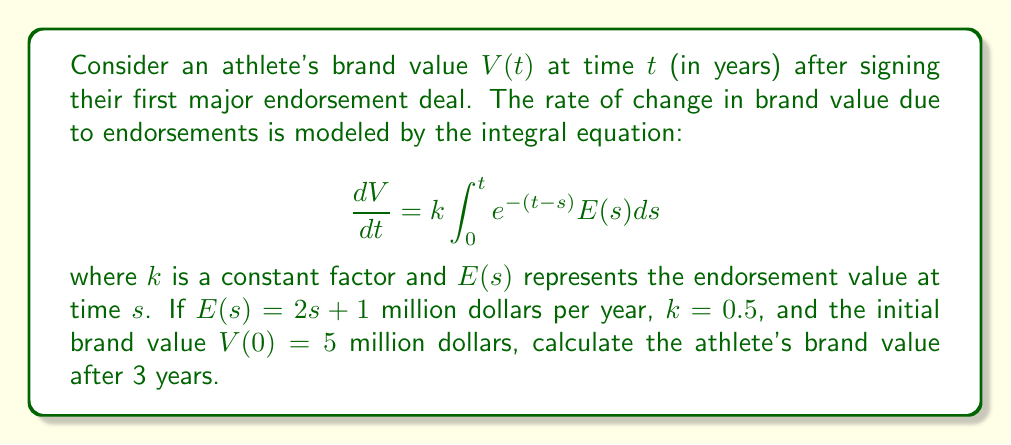Provide a solution to this math problem. To solve this problem, we'll follow these steps:

1) First, we need to solve the integral equation to find $V(t)$:

   $$\frac{dV}{dt} = k\int_0^t e^{-(t-s)}E(s)ds$$

2) Substitute the given $E(s) = 2s + 1$:

   $$\frac{dV}{dt} = k\int_0^t e^{-(t-s)}(2s + 1)ds$$

3) Solve the integral:

   $$\begin{align*}
   \frac{dV}{dt} &= k\int_0^t e^{-(t-s)}(2s + 1)ds \\
   &= k\left[-e^{-(t-s)}(2s + 1) - 2e^{-(t-s)}\right]_0^t \\
   &= k\left[-(2t + 1) - 2 + (1 + 2e^{-t})\right] \\
   &= k(-2t + 2e^{-t} - 1)
   \end{align*}$$

4) Integrate both sides with respect to $t$:

   $$\begin{align*}
   V(t) &= k\int (-2t + 2e^{-t} - 1)dt \\
   &= k(-t^2 - 2e^{-t} - t) + C
   \end{align*}$$

5) Use the initial condition $V(0) = 5$ to find $C$:

   $$5 = k(0 - 2 - 0) + C$$
   $$C = 5 + 2k$$

6) Therefore, the brand value function is:

   $$V(t) = k(-t^2 - 2e^{-t} - t) + 5 + 2k$$

7) Substitute $k = 0.5$ and $t = 3$:

   $$\begin{align*}
   V(3) &= 0.5(-3^2 - 2e^{-3} - 3) + 5 + 2(0.5) \\
   &= 0.5(-9 - 2e^{-3} - 3) + 6 \\
   &= -4.5 - e^{-3} - 1.5 + 6 \\
   &= 0 - e^{-3}
   \end{align*}$$

8) Evaluate $e^{-3} \approx 0.0498$:

   $$V(3) \approx 0 - 0.0498 = -0.0498$$

Therefore, the athlete's brand value after 3 years is approximately -0.0498 million dollars, or -$49,800.
Answer: $-$0.0498 million dollars 